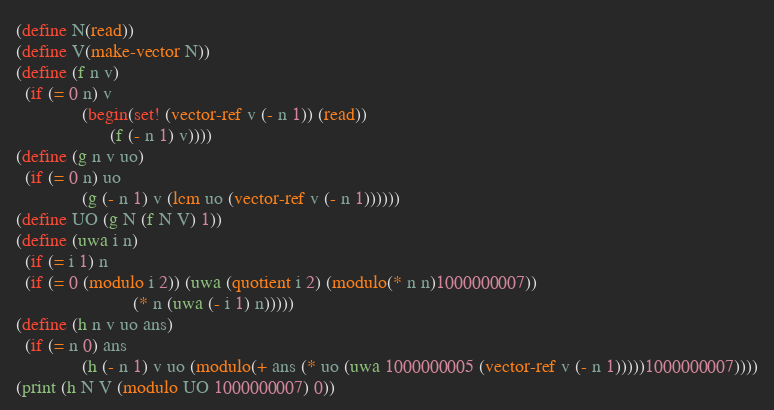<code> <loc_0><loc_0><loc_500><loc_500><_Scheme_>(define N(read))
(define V(make-vector N))
(define (f n v)
  (if (= 0 n) v
              (begin(set! (vector-ref v (- n 1)) (read))
                    (f (- n 1) v))))
(define (g n v uo)
  (if (= 0 n) uo
              (g (- n 1) v (lcm uo (vector-ref v (- n 1))))))
(define UO (g N (f N V) 1))
(define (uwa i n)
  (if (= i 1) n
  (if (= 0 (modulo i 2)) (uwa (quotient i 2) (modulo(* n n)1000000007))
                         (* n (uwa (- i 1) n)))))
(define (h n v uo ans)
  (if (= n 0) ans
              (h (- n 1) v uo (modulo(+ ans (* uo (uwa 1000000005 (vector-ref v (- n 1)))))1000000007))))
(print (h N V (modulo UO 1000000007) 0))</code> 